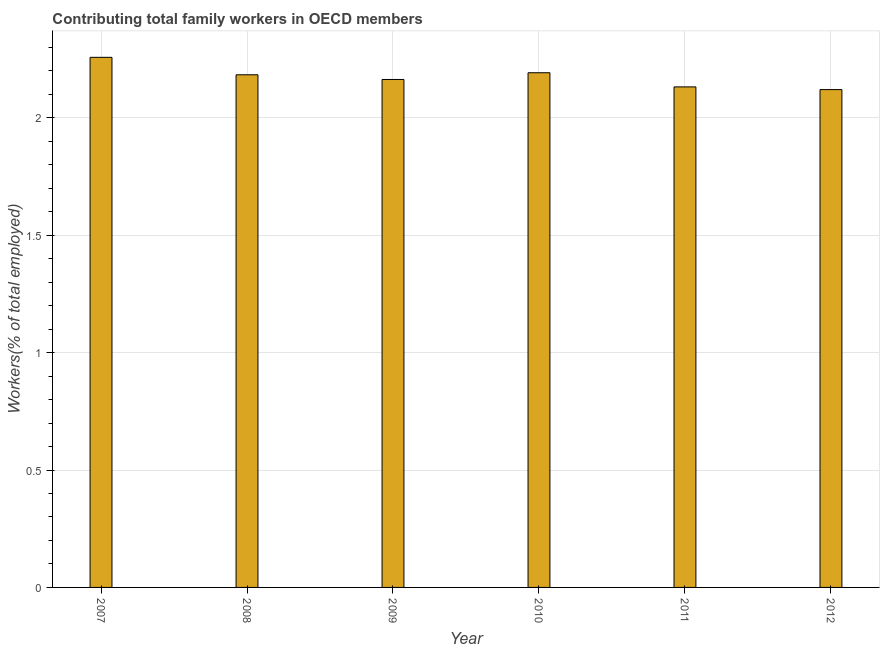What is the title of the graph?
Offer a very short reply. Contributing total family workers in OECD members. What is the label or title of the Y-axis?
Your response must be concise. Workers(% of total employed). What is the contributing family workers in 2008?
Provide a short and direct response. 2.18. Across all years, what is the maximum contributing family workers?
Make the answer very short. 2.26. Across all years, what is the minimum contributing family workers?
Keep it short and to the point. 2.12. In which year was the contributing family workers minimum?
Your answer should be compact. 2012. What is the sum of the contributing family workers?
Make the answer very short. 13.05. What is the difference between the contributing family workers in 2007 and 2011?
Your response must be concise. 0.13. What is the average contributing family workers per year?
Make the answer very short. 2.17. What is the median contributing family workers?
Keep it short and to the point. 2.17. In how many years, is the contributing family workers greater than 1 %?
Keep it short and to the point. 6. Do a majority of the years between 2011 and 2012 (inclusive) have contributing family workers greater than 2 %?
Keep it short and to the point. Yes. What is the ratio of the contributing family workers in 2007 to that in 2012?
Your response must be concise. 1.06. Is the contributing family workers in 2010 less than that in 2012?
Keep it short and to the point. No. Is the difference between the contributing family workers in 2007 and 2010 greater than the difference between any two years?
Offer a very short reply. No. What is the difference between the highest and the second highest contributing family workers?
Your answer should be compact. 0.07. What is the difference between the highest and the lowest contributing family workers?
Provide a succinct answer. 0.14. In how many years, is the contributing family workers greater than the average contributing family workers taken over all years?
Offer a terse response. 3. Are all the bars in the graph horizontal?
Keep it short and to the point. No. How many years are there in the graph?
Your response must be concise. 6. Are the values on the major ticks of Y-axis written in scientific E-notation?
Keep it short and to the point. No. What is the Workers(% of total employed) in 2007?
Make the answer very short. 2.26. What is the Workers(% of total employed) of 2008?
Provide a succinct answer. 2.18. What is the Workers(% of total employed) of 2009?
Offer a terse response. 2.16. What is the Workers(% of total employed) of 2010?
Your response must be concise. 2.19. What is the Workers(% of total employed) of 2011?
Your answer should be very brief. 2.13. What is the Workers(% of total employed) in 2012?
Give a very brief answer. 2.12. What is the difference between the Workers(% of total employed) in 2007 and 2008?
Your answer should be very brief. 0.07. What is the difference between the Workers(% of total employed) in 2007 and 2009?
Provide a succinct answer. 0.09. What is the difference between the Workers(% of total employed) in 2007 and 2010?
Make the answer very short. 0.07. What is the difference between the Workers(% of total employed) in 2007 and 2011?
Keep it short and to the point. 0.13. What is the difference between the Workers(% of total employed) in 2007 and 2012?
Provide a succinct answer. 0.14. What is the difference between the Workers(% of total employed) in 2008 and 2009?
Keep it short and to the point. 0.02. What is the difference between the Workers(% of total employed) in 2008 and 2010?
Your answer should be compact. -0.01. What is the difference between the Workers(% of total employed) in 2008 and 2011?
Make the answer very short. 0.05. What is the difference between the Workers(% of total employed) in 2008 and 2012?
Your answer should be very brief. 0.06. What is the difference between the Workers(% of total employed) in 2009 and 2010?
Your response must be concise. -0.03. What is the difference between the Workers(% of total employed) in 2009 and 2011?
Your answer should be very brief. 0.03. What is the difference between the Workers(% of total employed) in 2009 and 2012?
Offer a terse response. 0.04. What is the difference between the Workers(% of total employed) in 2010 and 2011?
Keep it short and to the point. 0.06. What is the difference between the Workers(% of total employed) in 2010 and 2012?
Your response must be concise. 0.07. What is the difference between the Workers(% of total employed) in 2011 and 2012?
Provide a short and direct response. 0.01. What is the ratio of the Workers(% of total employed) in 2007 to that in 2008?
Offer a terse response. 1.03. What is the ratio of the Workers(% of total employed) in 2007 to that in 2009?
Offer a very short reply. 1.04. What is the ratio of the Workers(% of total employed) in 2007 to that in 2010?
Your answer should be compact. 1.03. What is the ratio of the Workers(% of total employed) in 2007 to that in 2011?
Your answer should be very brief. 1.06. What is the ratio of the Workers(% of total employed) in 2007 to that in 2012?
Provide a short and direct response. 1.06. What is the ratio of the Workers(% of total employed) in 2008 to that in 2009?
Keep it short and to the point. 1.01. What is the ratio of the Workers(% of total employed) in 2008 to that in 2010?
Offer a very short reply. 1. What is the ratio of the Workers(% of total employed) in 2009 to that in 2010?
Ensure brevity in your answer.  0.99. What is the ratio of the Workers(% of total employed) in 2009 to that in 2011?
Make the answer very short. 1.01. What is the ratio of the Workers(% of total employed) in 2009 to that in 2012?
Your answer should be very brief. 1.02. What is the ratio of the Workers(% of total employed) in 2010 to that in 2011?
Give a very brief answer. 1.03. What is the ratio of the Workers(% of total employed) in 2010 to that in 2012?
Offer a very short reply. 1.03. What is the ratio of the Workers(% of total employed) in 2011 to that in 2012?
Make the answer very short. 1. 